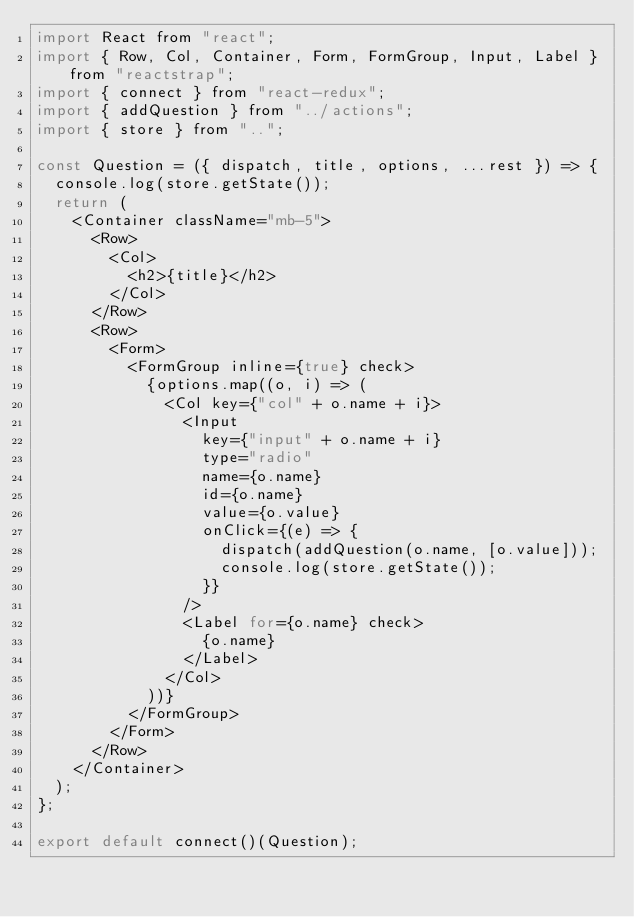Convert code to text. <code><loc_0><loc_0><loc_500><loc_500><_JavaScript_>import React from "react";
import { Row, Col, Container, Form, FormGroup, Input, Label } from "reactstrap";
import { connect } from "react-redux";
import { addQuestion } from "../actions";
import { store } from "..";

const Question = ({ dispatch, title, options, ...rest }) => {
  console.log(store.getState());
  return (
    <Container className="mb-5">
      <Row>
        <Col>
          <h2>{title}</h2>
        </Col>
      </Row>
      <Row>
        <Form>
          <FormGroup inline={true} check>
            {options.map((o, i) => (
              <Col key={"col" + o.name + i}>
                <Input
                  key={"input" + o.name + i}
                  type="radio"
                  name={o.name}
                  id={o.name}
                  value={o.value}
                  onClick={(e) => {
                    dispatch(addQuestion(o.name, [o.value]));
                    console.log(store.getState());
                  }}
                />
                <Label for={o.name} check>
                  {o.name}
                </Label>
              </Col>
            ))}
          </FormGroup>
        </Form>
      </Row>
    </Container>
  );
};

export default connect()(Question);
</code> 